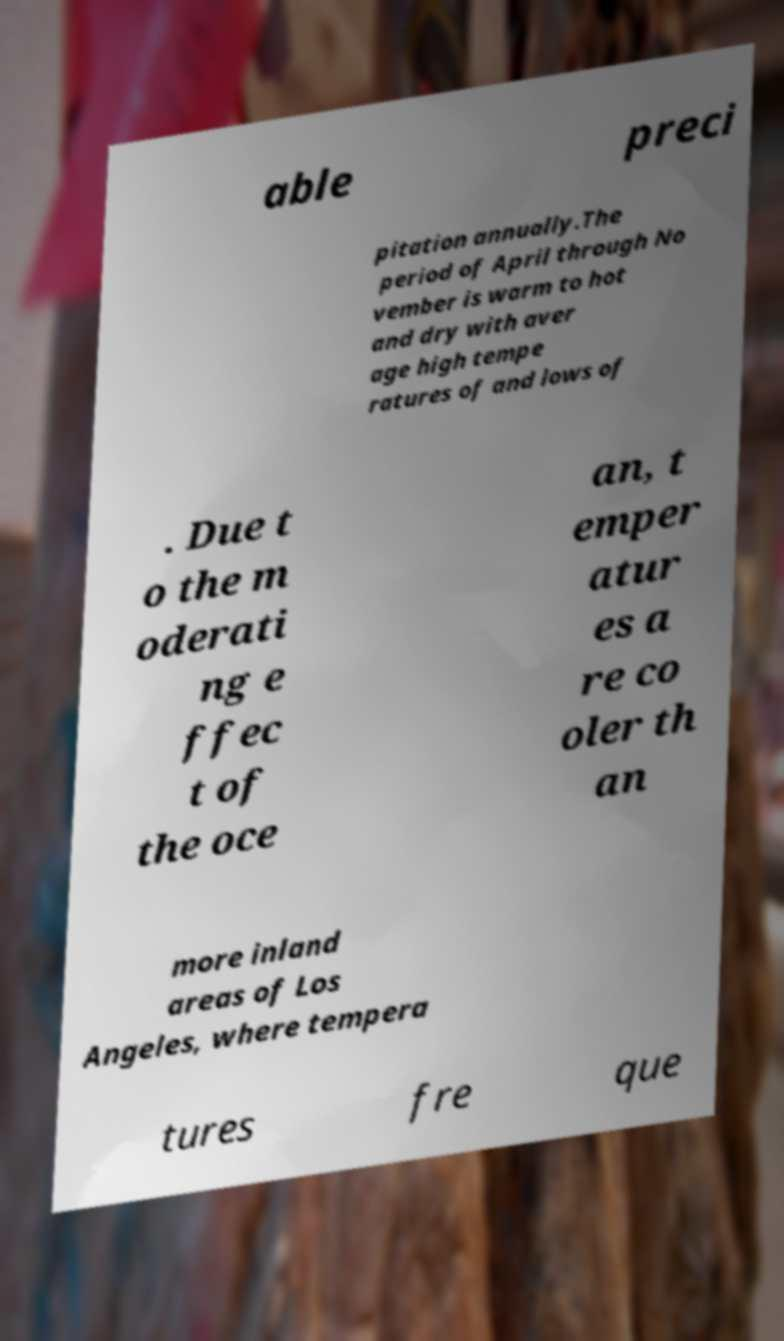What messages or text are displayed in this image? I need them in a readable, typed format. able preci pitation annually.The period of April through No vember is warm to hot and dry with aver age high tempe ratures of and lows of . Due t o the m oderati ng e ffec t of the oce an, t emper atur es a re co oler th an more inland areas of Los Angeles, where tempera tures fre que 